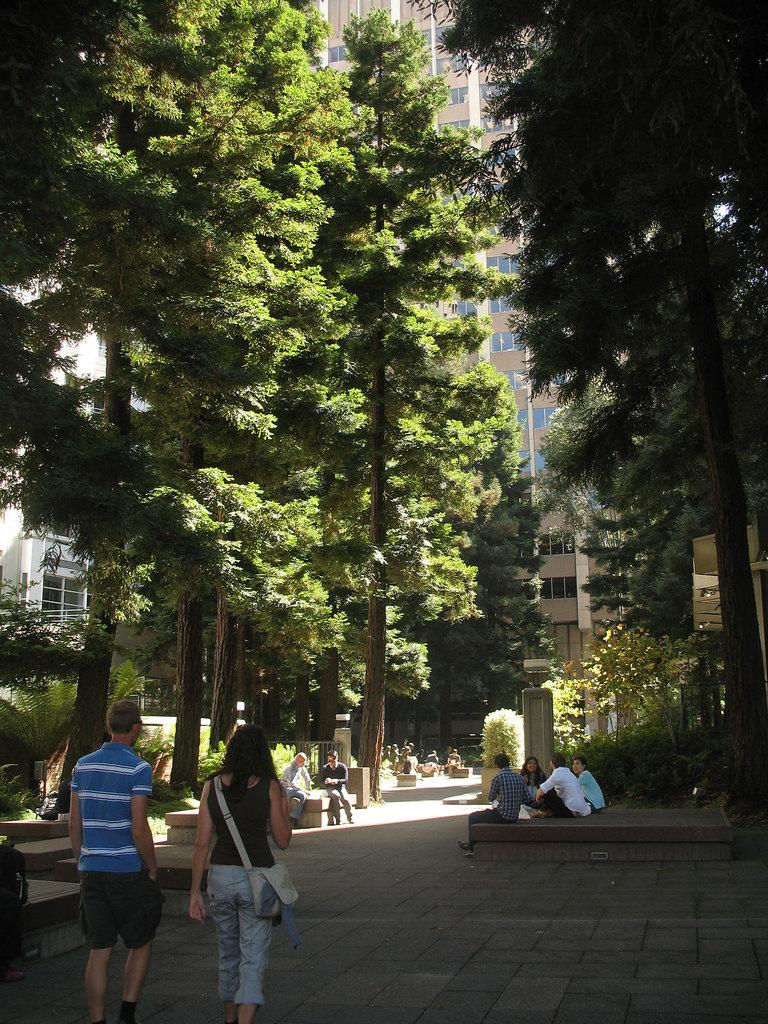What are the people in the image doing? The people in the image are on a path. What type of natural elements can be seen in the image? There are plants and trees in the image. What type of man-made structures are visible in the image? There are buildings in the image. What other objects can be seen in the image besides the people, plants, trees, and buildings? There are other objects in the image. Can you see a tiger in the image? No, there is no tiger present in the image. What type of muscle is being exercised by the people in the image? There is no indication of any exercise or muscle activity in the image; the people are simply on a path. 